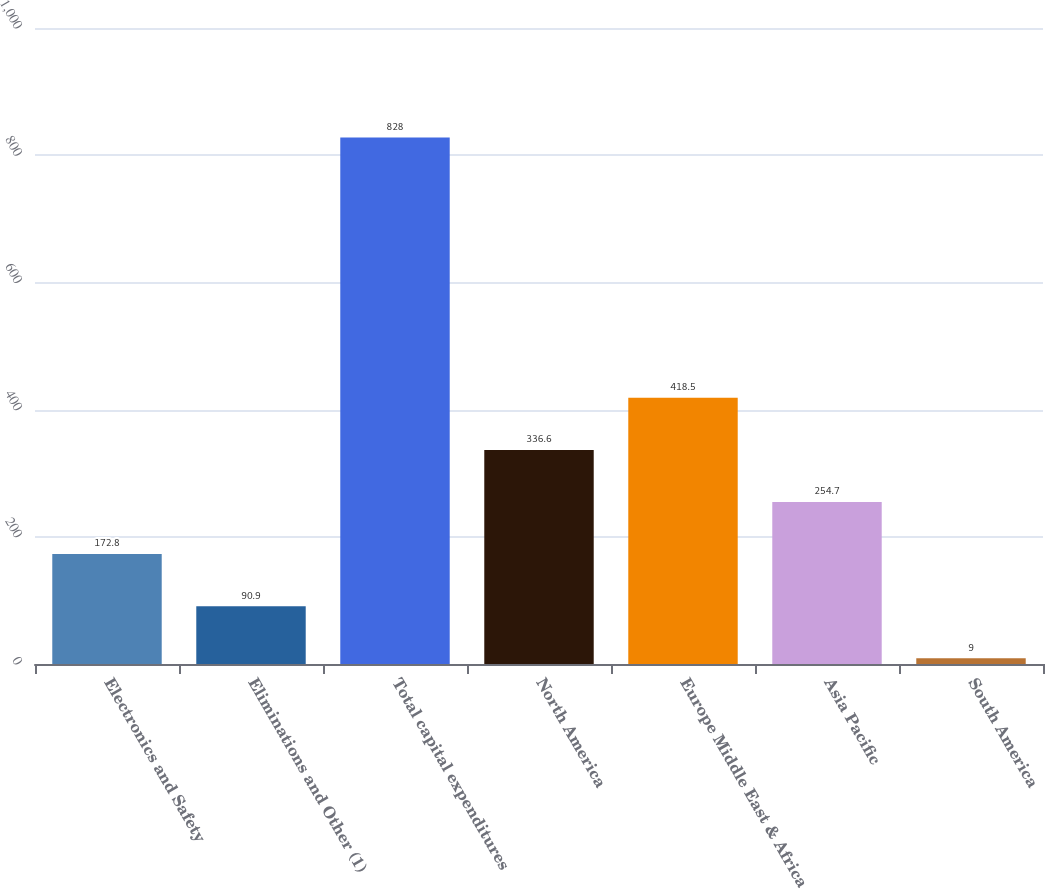Convert chart to OTSL. <chart><loc_0><loc_0><loc_500><loc_500><bar_chart><fcel>Electronics and Safety<fcel>Eliminations and Other (1)<fcel>Total capital expenditures<fcel>North America<fcel>Europe Middle East & Africa<fcel>Asia Pacific<fcel>South America<nl><fcel>172.8<fcel>90.9<fcel>828<fcel>336.6<fcel>418.5<fcel>254.7<fcel>9<nl></chart> 